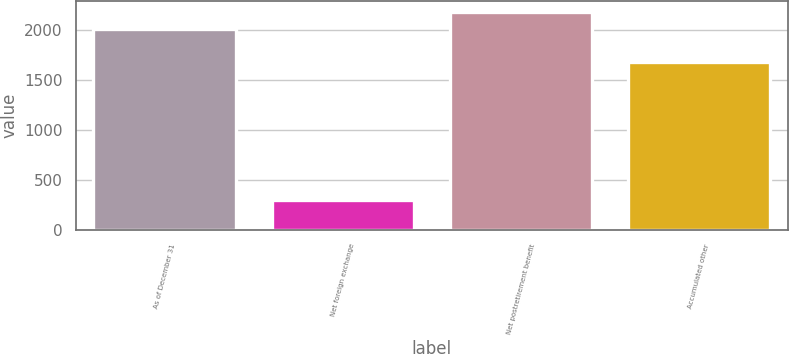Convert chart to OTSL. <chart><loc_0><loc_0><loc_500><loc_500><bar_chart><fcel>As of December 31<fcel>Net foreign exchange<fcel>Net postretirement benefit<fcel>Accumulated other<nl><fcel>2009<fcel>301<fcel>2180.9<fcel>1675<nl></chart> 